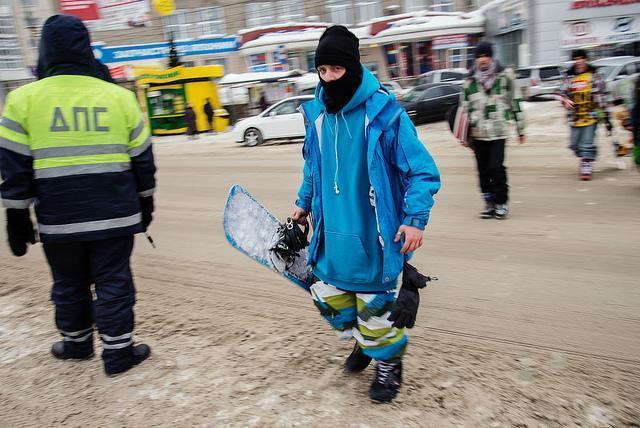How many people are in this picture?
Give a very brief answer. 4. How many people are visible?
Give a very brief answer. 4. How many teddy bears are there?
Give a very brief answer. 0. 